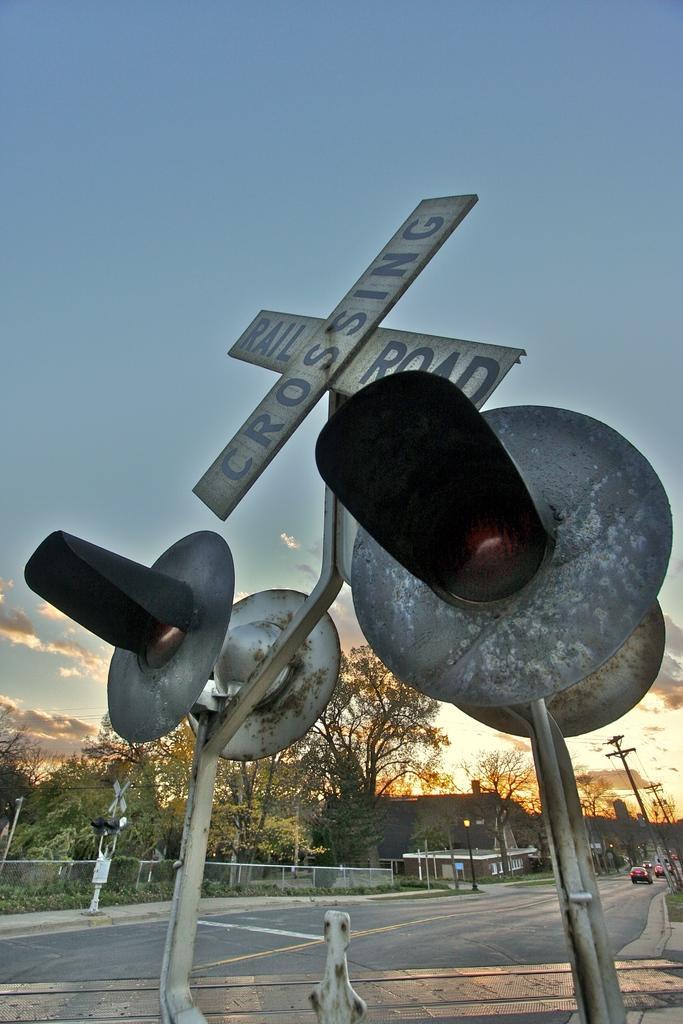Describe this image in one or two sentences. In this picture I can see the crossing signal in front and I can see the boards, on which there are words written. In the background I can see the road, on which there are few cars and I can also see few buildings, poles, wires, fencing and the sky which is a bit cloudy. 